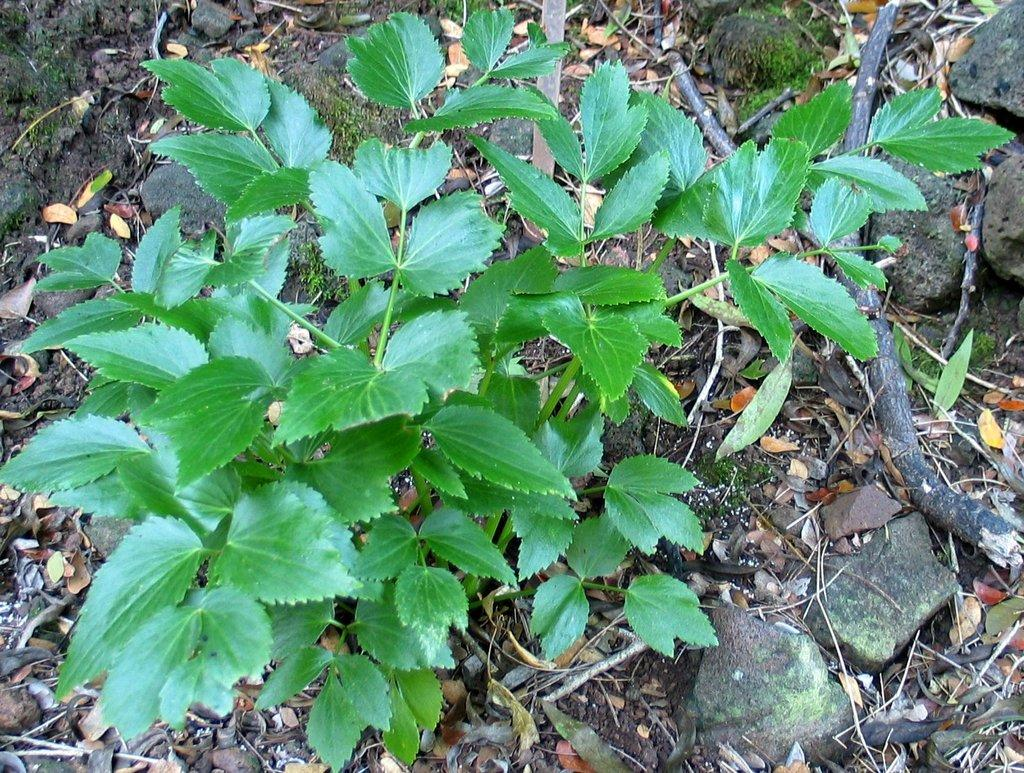What is the main subject in the middle of the picture? There is a tree in the middle of the picture. What is the color of the leaves on the tree? The tree has green leaves. What type of pets can be seen playing with a balloon in the image? There are no pets or balloons present in the image; it features a tree with green leaves. 